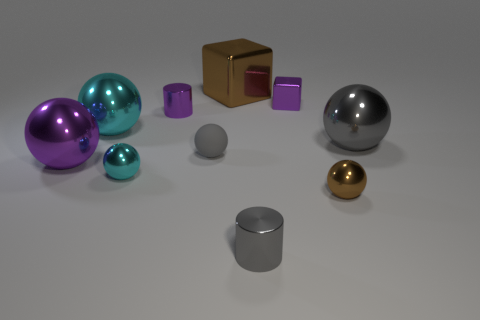Is there a small brown shiny object behind the purple object that is behind the tiny purple shiny cylinder?
Your answer should be very brief. No. What size is the shiny ball that is the same color as the small matte object?
Provide a short and direct response. Large. There is a brown thing that is to the left of the purple block; what is its shape?
Offer a terse response. Cube. What number of purple metal objects are on the right side of the purple thing left of the big cyan metallic thing that is on the left side of the purple metallic block?
Offer a very short reply. 2. There is a purple metal ball; is it the same size as the gray shiny thing behind the big purple ball?
Your answer should be very brief. Yes. There is a brown thing that is left of the tiny shiny cylinder that is in front of the gray rubber object; what size is it?
Keep it short and to the point. Large. What number of small balls have the same material as the big cyan ball?
Keep it short and to the point. 2. Are any metal cylinders visible?
Offer a very short reply. Yes. There is a brown thing in front of the big gray metallic sphere; how big is it?
Keep it short and to the point. Small. How many tiny metal balls have the same color as the small matte ball?
Offer a terse response. 0. 